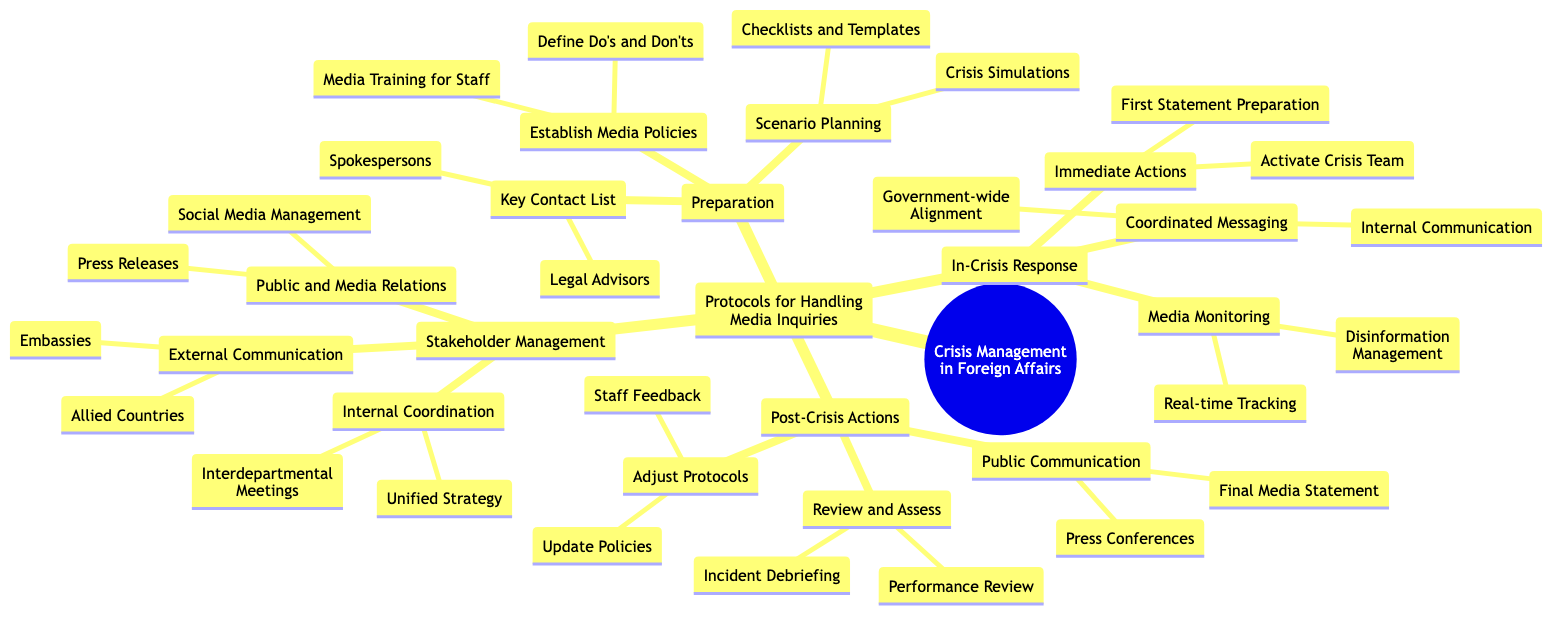What are the three main categories in the diagram? The diagram has three main categories: Preparation, In-Crisis Response, and Post-Crisis Actions. Each of these categories has its own subcategories, but the broad framework can be identified quickly with these three main divisions.
Answer: Preparation, In-Crisis Response, Post-Crisis Actions How many items are listed under "Preparation"? Under the "Preparation" category, there are three subcategories: "Establish Media Policies," "Scenario Planning," and "Key Contact List." Each of these has multiple items listed, so we focus only on the main subcategories here.
Answer: 3 What action is taken first during the In-Crisis Response? The first action listed under "Immediate Actions" in the "In-Crisis Response" category is "Activate Crisis Team." This indicates that during a crisis, the priority is to mobilize the team that handles the situation.
Answer: Activate Crisis Team What is included in the "Key Contact List"? The "Key Contact List" contains two important items: "Spokespersons" and "Legal Advisors." These roles are crucial for handling media inquiries effectively and ensuring legal compliance.
Answer: Spokespersons, Legal Advisors Which entities are involved in External Communication? The "External Communication" category includes "Embassies" and "Allied Countries," indicating that communication efforts during a crisis will extend beyond domestic stakeholders to international partners.
Answer: Embassies, Allied Countries What is the purpose of "Media Monitoring"? "Media Monitoring" serves two main purposes: "Real-time Tracking" and "Disinformation Management." This is crucial for understanding public perception and countering false information during a crisis.
Answer: Real-time Tracking, Disinformation Management How many steps are involved in "Post-Crisis Actions"? The "Post-Crisis Actions" category has three clear steps: "Review and Assess," "Adjust Protocols," and "Public Communication." This structure allows for a systematic approach to learning from the crisis.
Answer: 3 What should a spokesperson focus on during the "Final Media Statement"? The spokesperson should focus on delivering the "Final Media Statement" as part of the "Public Communication" stage. This is essential to control the narrative and provide closure to the media.
Answer: Final Media Statement What kind of training is suggested for staff? The diagram indicates that "Media Training for Staff" is part of the "Establish Media Policies" under "Preparation." This training is necessary to ensure that staff are prepared for interactions with the media during a crisis.
Answer: Media Training for Staff 